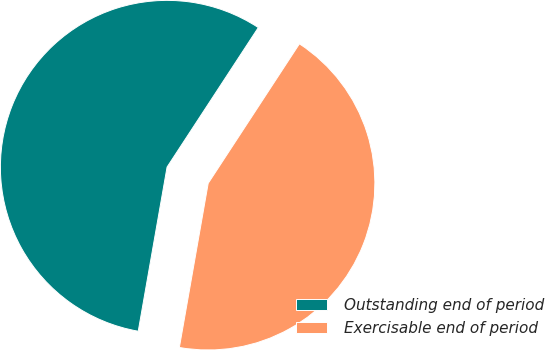Convert chart. <chart><loc_0><loc_0><loc_500><loc_500><pie_chart><fcel>Outstanding end of period<fcel>Exercisable end of period<nl><fcel>56.45%<fcel>43.55%<nl></chart> 